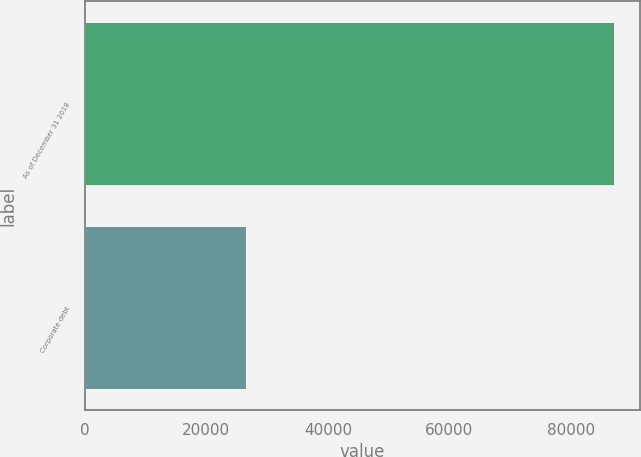Convert chart. <chart><loc_0><loc_0><loc_500><loc_500><bar_chart><fcel>As of December 31 2018<fcel>Corporate debt<nl><fcel>87028<fcel>26476<nl></chart> 